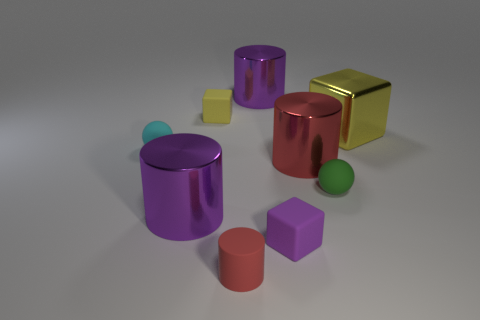Subtract 1 cylinders. How many cylinders are left? 3 Add 1 yellow blocks. How many objects exist? 10 Subtract all cylinders. How many objects are left? 5 Add 7 tiny rubber cylinders. How many tiny rubber cylinders exist? 8 Subtract 2 red cylinders. How many objects are left? 7 Subtract all small green balls. Subtract all big brown objects. How many objects are left? 8 Add 3 small matte cylinders. How many small matte cylinders are left? 4 